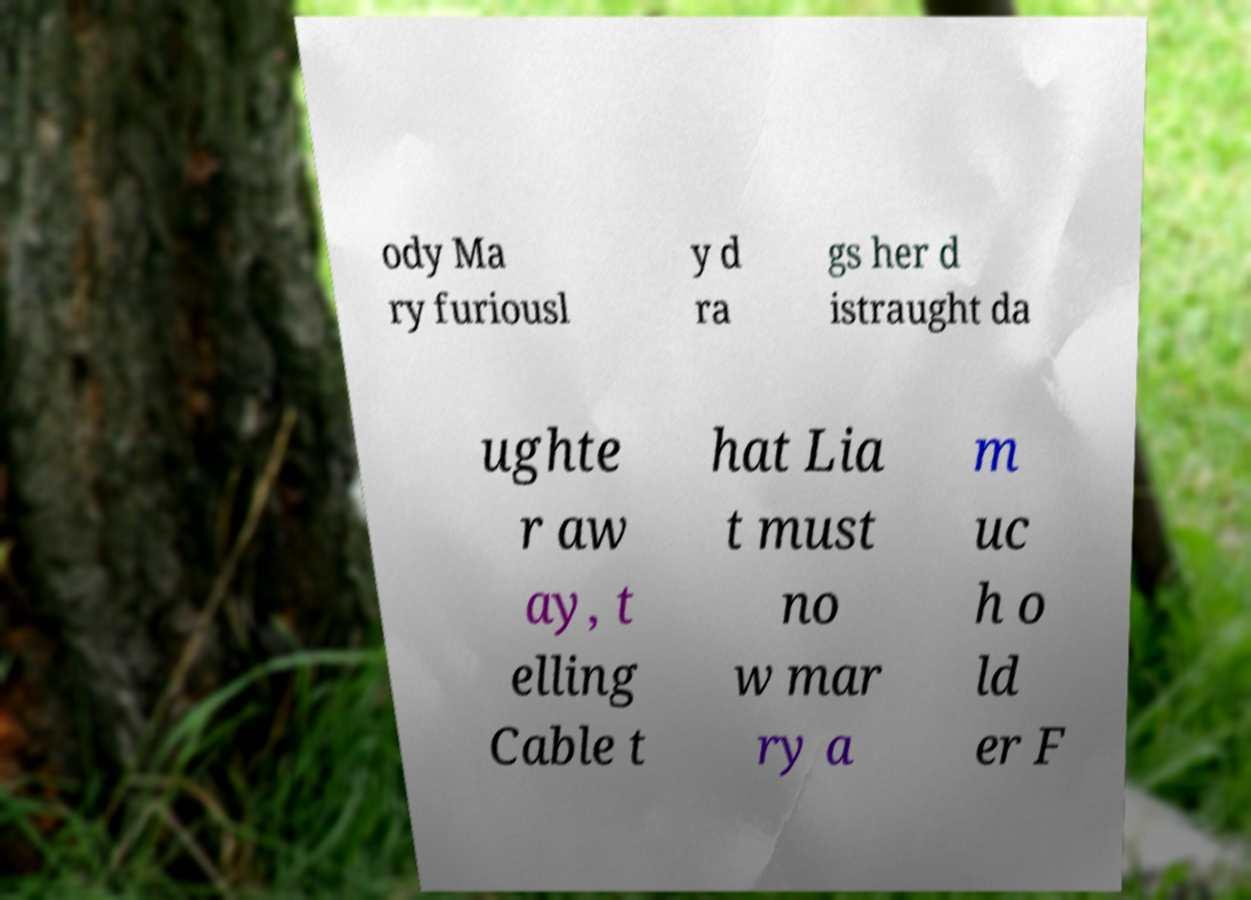Please identify and transcribe the text found in this image. ody Ma ry furiousl y d ra gs her d istraught da ughte r aw ay, t elling Cable t hat Lia t must no w mar ry a m uc h o ld er F 